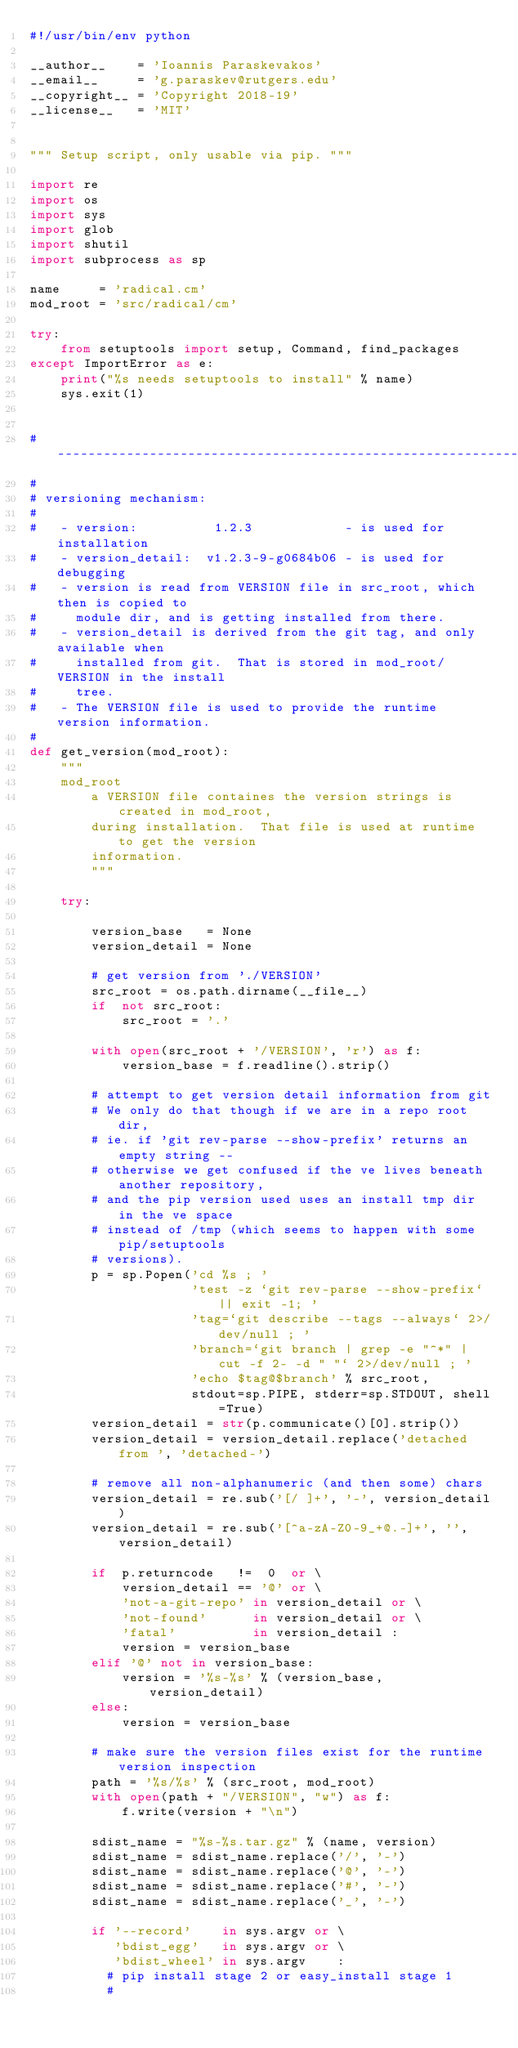<code> <loc_0><loc_0><loc_500><loc_500><_Python_>#!/usr/bin/env python

__author__    = 'Ioannis Paraskevakos'
__email__     = 'g.paraskev@rutgers.edu'
__copyright__ = 'Copyright 2018-19'
__license__   = 'MIT'


""" Setup script, only usable via pip. """

import re
import os
import sys
import glob
import shutil
import subprocess as sp

name     = 'radical.cm'
mod_root = 'src/radical/cm'

try:
    from setuptools import setup, Command, find_packages
except ImportError as e:
    print("%s needs setuptools to install" % name)
    sys.exit(1)


# ------------------------------------------------------------------------------
#
# versioning mechanism:
#
#   - version:          1.2.3            - is used for installation
#   - version_detail:  v1.2.3-9-g0684b06 - is used for debugging
#   - version is read from VERSION file in src_root, which then is copied to
#     module dir, and is getting installed from there.
#   - version_detail is derived from the git tag, and only available when
#     installed from git.  That is stored in mod_root/VERSION in the install
#     tree.
#   - The VERSION file is used to provide the runtime version information.
#
def get_version(mod_root):
    """
    mod_root
        a VERSION file containes the version strings is created in mod_root,
        during installation.  That file is used at runtime to get the version
        information.
        """

    try:

        version_base   = None
        version_detail = None

        # get version from './VERSION'
        src_root = os.path.dirname(__file__)
        if  not src_root:
            src_root = '.'

        with open(src_root + '/VERSION', 'r') as f:
            version_base = f.readline().strip()

        # attempt to get version detail information from git
        # We only do that though if we are in a repo root dir,
        # ie. if 'git rev-parse --show-prefix' returns an empty string --
        # otherwise we get confused if the ve lives beneath another repository,
        # and the pip version used uses an install tmp dir in the ve space
        # instead of /tmp (which seems to happen with some pip/setuptools
        # versions).
        p = sp.Popen('cd %s ; '
                     'test -z `git rev-parse --show-prefix` || exit -1; '
                     'tag=`git describe --tags --always` 2>/dev/null ; '
                     'branch=`git branch | grep -e "^*" | cut -f 2- -d " "` 2>/dev/null ; '
                     'echo $tag@$branch' % src_root,
                     stdout=sp.PIPE, stderr=sp.STDOUT, shell=True)
        version_detail = str(p.communicate()[0].strip())
        version_detail = version_detail.replace('detached from ', 'detached-')

        # remove all non-alphanumeric (and then some) chars
        version_detail = re.sub('[/ ]+', '-', version_detail)
        version_detail = re.sub('[^a-zA-Z0-9_+@.-]+', '', version_detail)

        if  p.returncode   !=  0  or \
            version_detail == '@' or \
            'not-a-git-repo' in version_detail or \
            'not-found'      in version_detail or \
            'fatal'          in version_detail :
            version = version_base
        elif '@' not in version_base:
            version = '%s-%s' % (version_base, version_detail)
        else:
            version = version_base

        # make sure the version files exist for the runtime version inspection
        path = '%s/%s' % (src_root, mod_root)
        with open(path + "/VERSION", "w") as f:
            f.write(version + "\n")

        sdist_name = "%s-%s.tar.gz" % (name, version)
        sdist_name = sdist_name.replace('/', '-')
        sdist_name = sdist_name.replace('@', '-')
        sdist_name = sdist_name.replace('#', '-')
        sdist_name = sdist_name.replace('_', '-')

        if '--record'    in sys.argv or \
           'bdist_egg'   in sys.argv or \
           'bdist_wheel' in sys.argv    :
          # pip install stage 2 or easy_install stage 1
          #</code> 